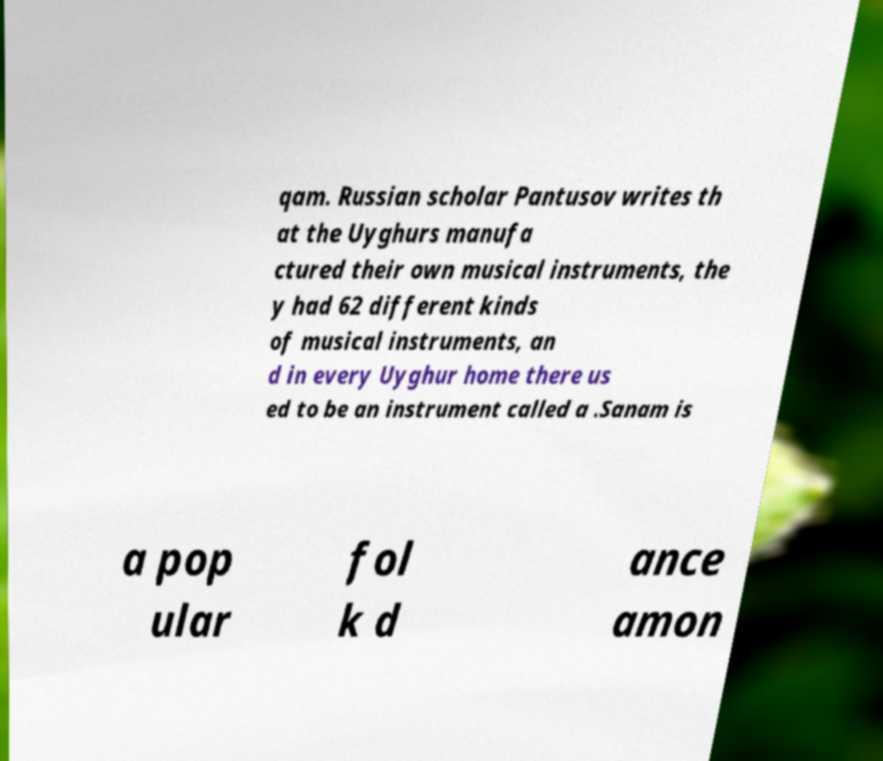For documentation purposes, I need the text within this image transcribed. Could you provide that? qam. Russian scholar Pantusov writes th at the Uyghurs manufa ctured their own musical instruments, the y had 62 different kinds of musical instruments, an d in every Uyghur home there us ed to be an instrument called a .Sanam is a pop ular fol k d ance amon 